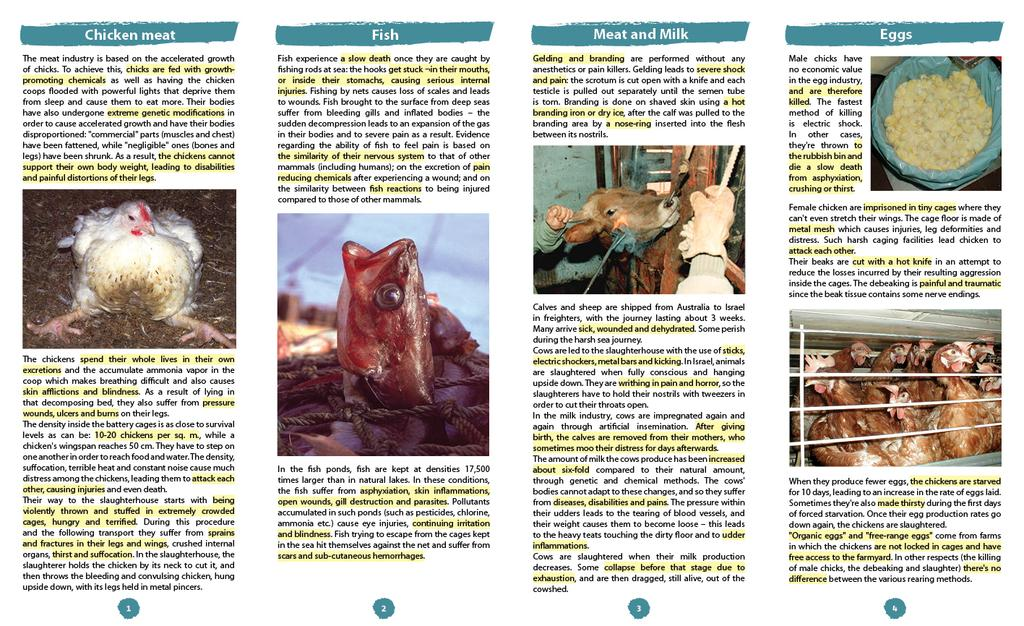What type of animals can be seen in the pictures in the image? There are pictures of hens, fish, and cows in the image. What else can be seen in the pictures in the image? There are pictures of eggs in the image. What is written on the paper in the image? There are letters on the paper in the image. Can you hear the bells ringing in the image? There are no bells present in the image, so it is not possible to hear them ringing. 